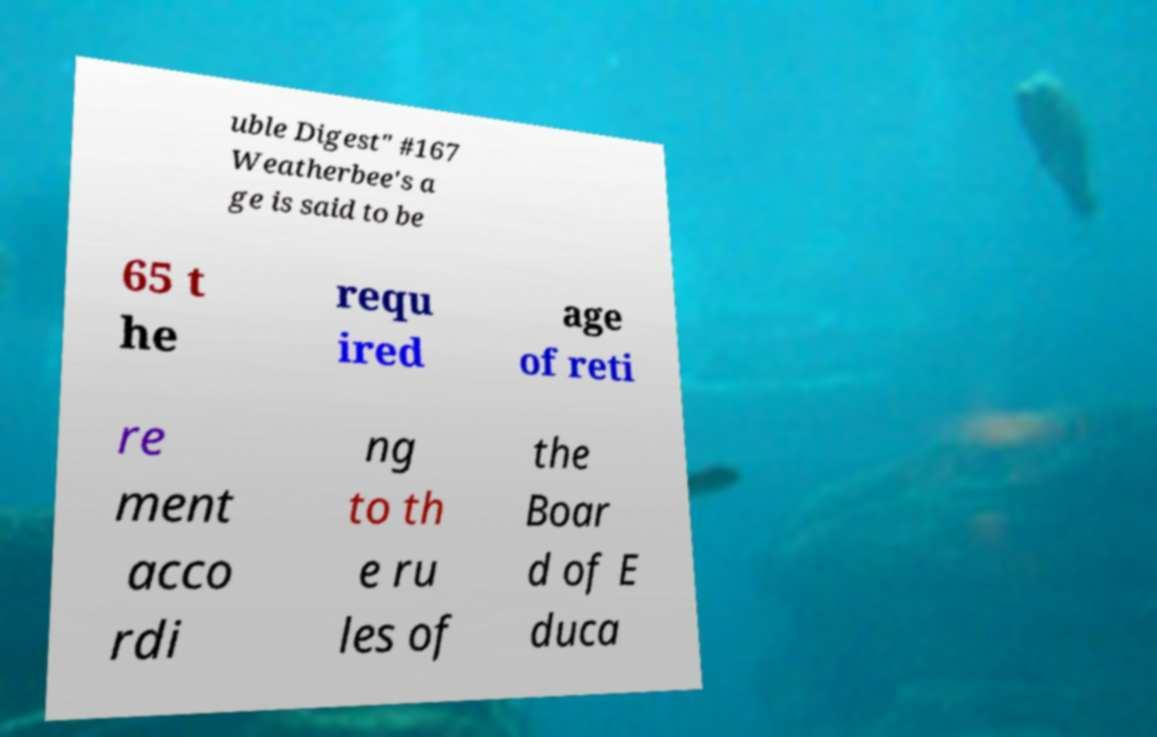For documentation purposes, I need the text within this image transcribed. Could you provide that? uble Digest" #167 Weatherbee's a ge is said to be 65 t he requ ired age of reti re ment acco rdi ng to th e ru les of the Boar d of E duca 